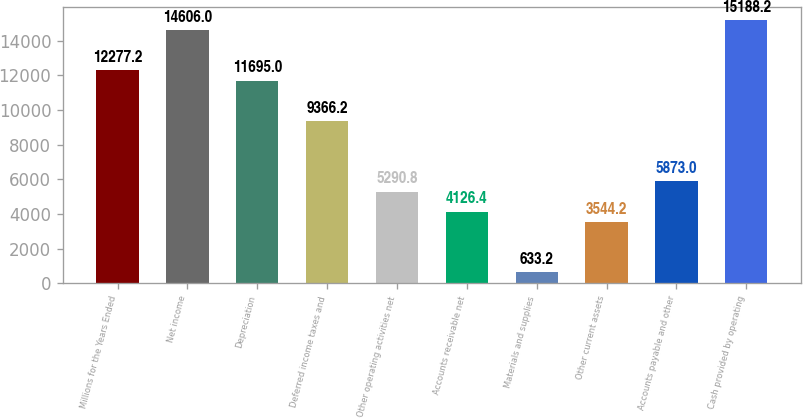<chart> <loc_0><loc_0><loc_500><loc_500><bar_chart><fcel>Millions for the Years Ended<fcel>Net income<fcel>Depreciation<fcel>Deferred income taxes and<fcel>Other operating activities net<fcel>Accounts receivable net<fcel>Materials and supplies<fcel>Other current assets<fcel>Accounts payable and other<fcel>Cash provided by operating<nl><fcel>12277.2<fcel>14606<fcel>11695<fcel>9366.2<fcel>5290.8<fcel>4126.4<fcel>633.2<fcel>3544.2<fcel>5873<fcel>15188.2<nl></chart> 